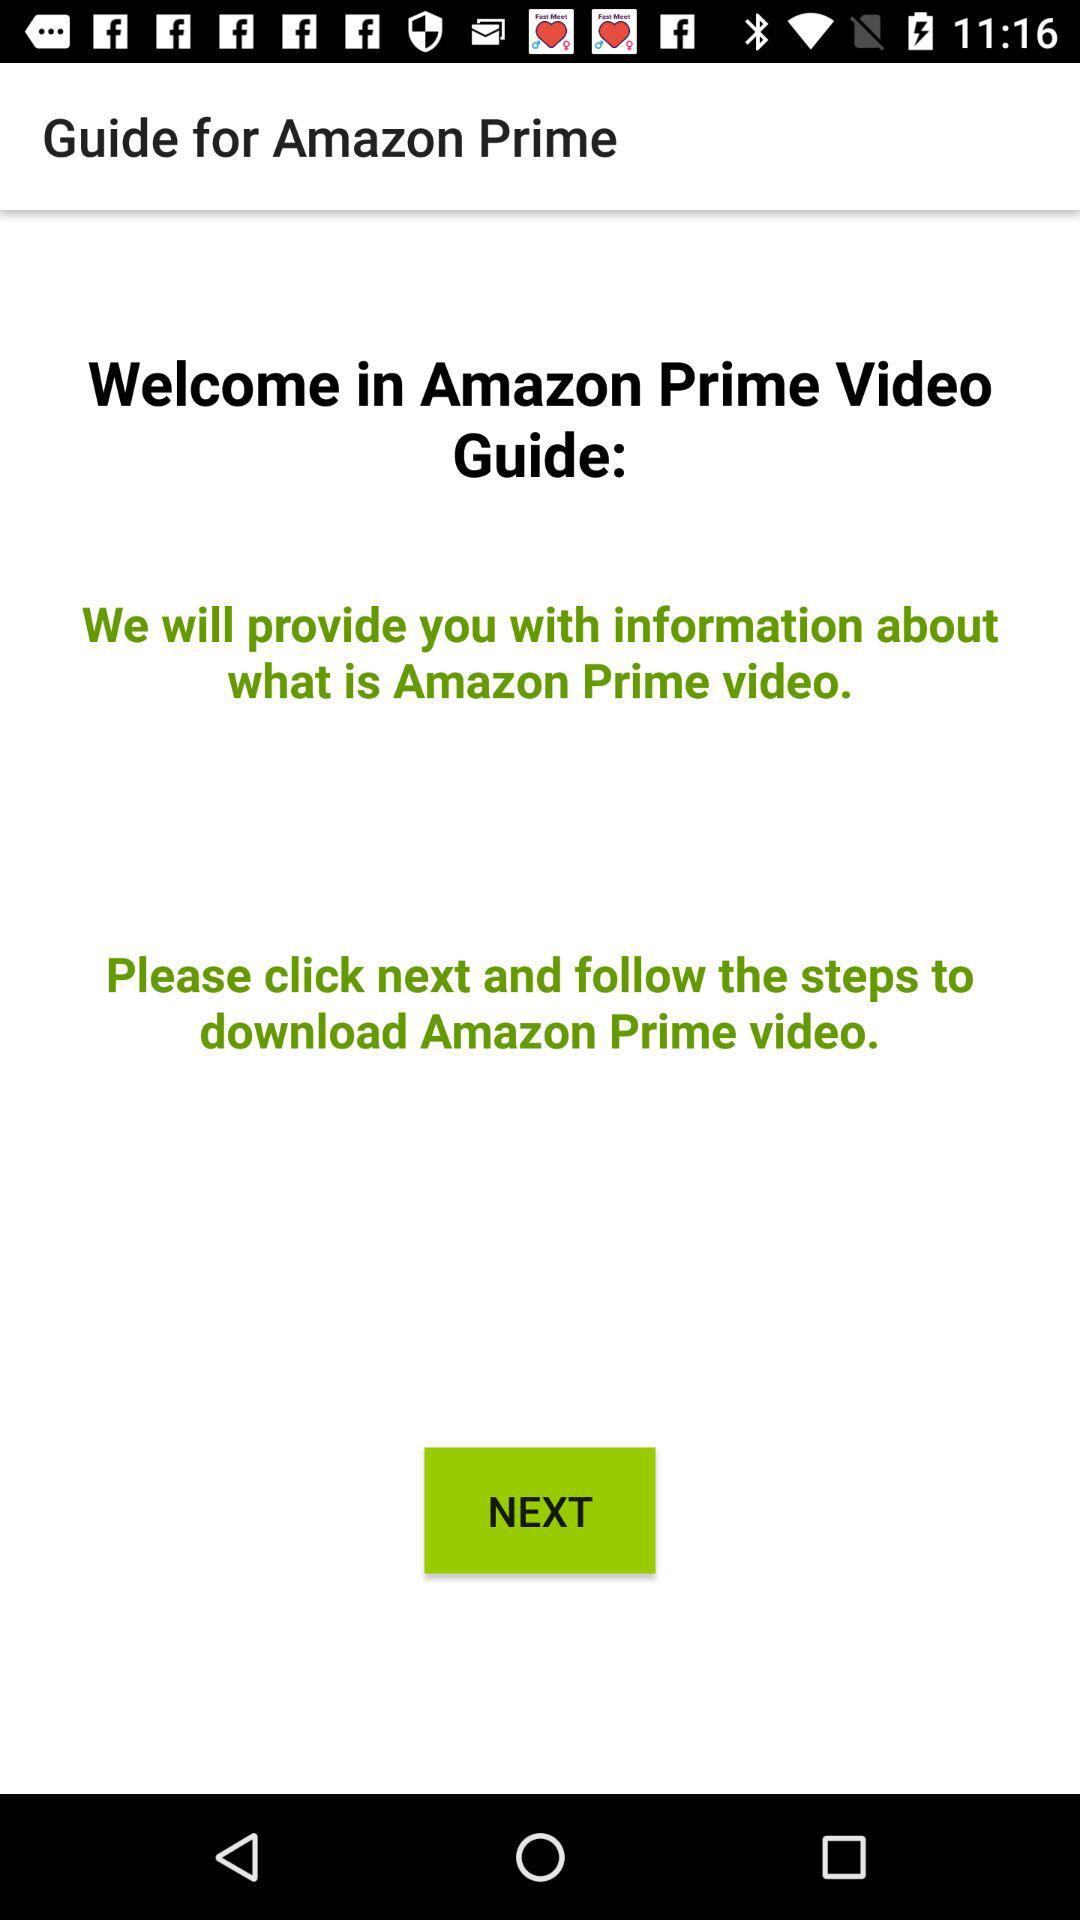What is the user's name?
When the provided information is insufficient, respond with <no answer>. <no answer> 